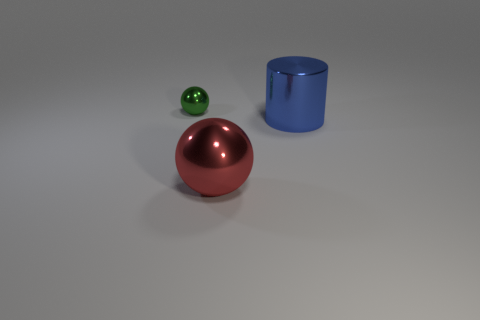Are there any other things that have the same size as the green object?
Offer a terse response. No. Are there fewer small green metal balls than tiny blue rubber blocks?
Provide a short and direct response. No. There is a tiny sphere; how many metal objects are in front of it?
Your response must be concise. 2. Do the red object and the blue thing have the same shape?
Provide a short and direct response. No. What number of metallic objects are to the right of the tiny green thing and to the left of the blue shiny object?
Your response must be concise. 1. How many things are either brown metal cylinders or things that are in front of the blue shiny cylinder?
Provide a succinct answer. 1. Is the number of tiny green metal objects greater than the number of gray blocks?
Your answer should be compact. Yes. What is the shape of the metallic thing in front of the large blue metal cylinder?
Make the answer very short. Sphere. How many other big red things have the same shape as the big red thing?
Provide a succinct answer. 0. What size is the thing on the right side of the big metallic object that is on the left side of the cylinder?
Make the answer very short. Large. 